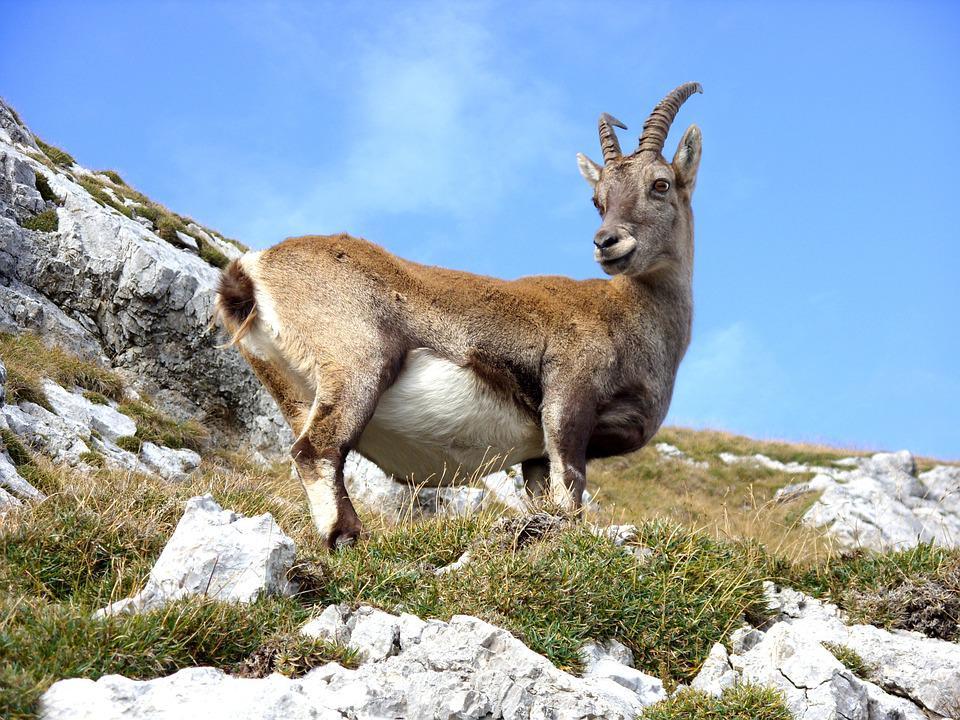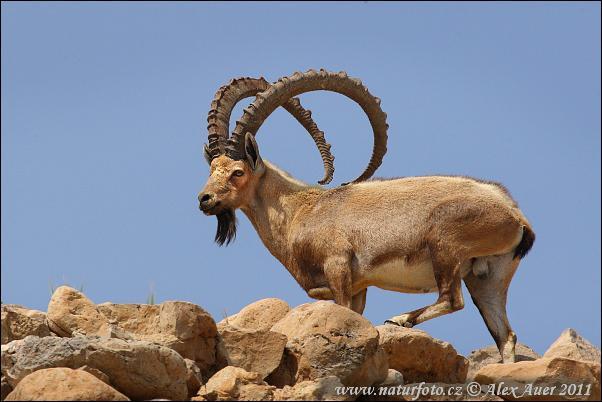The first image is the image on the left, the second image is the image on the right. Given the left and right images, does the statement "A different kind of animal is behind a sheep with a large set of horns in one image." hold true? Answer yes or no. No. The first image is the image on the left, the second image is the image on the right. Given the left and right images, does the statement "The sky can be seen in the image on the right." hold true? Answer yes or no. Yes. 